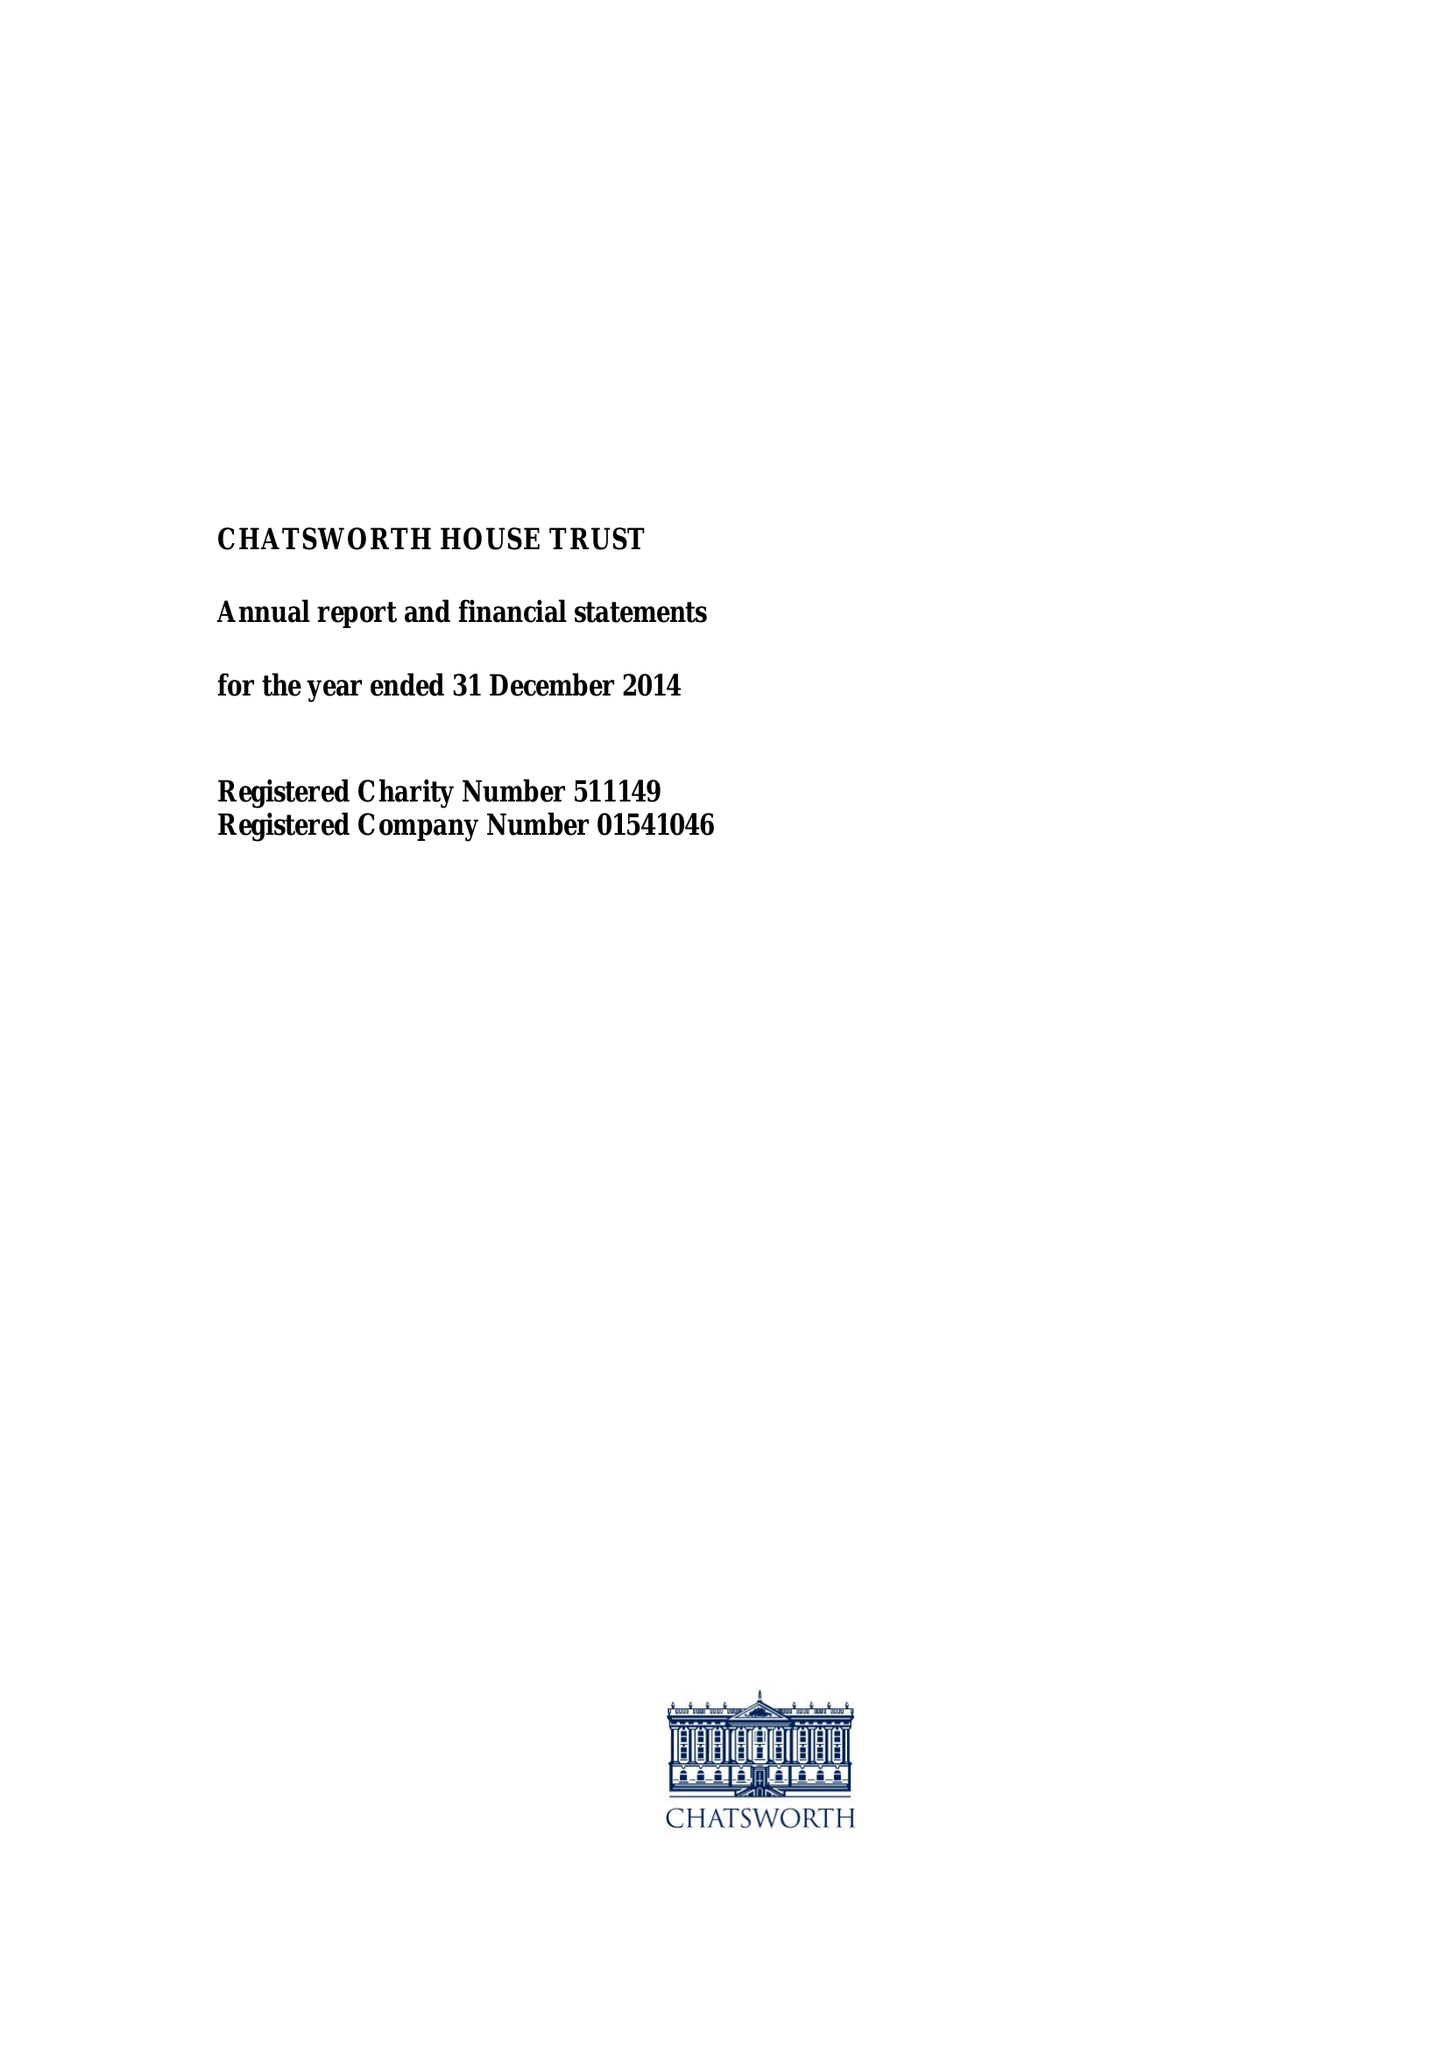What is the value for the address__street_line?
Answer the question using a single word or phrase. None 